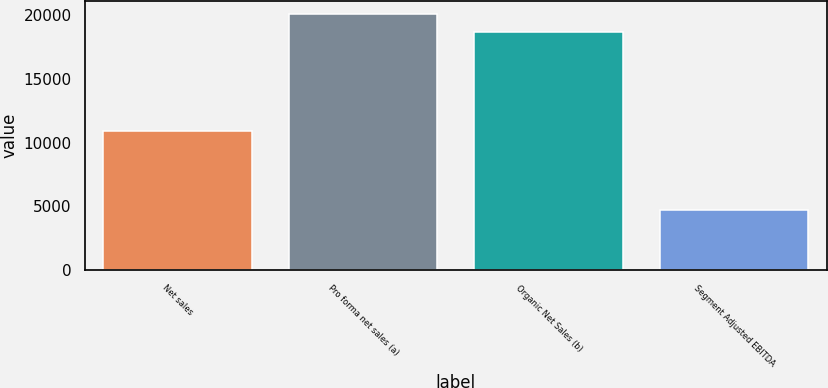Convert chart. <chart><loc_0><loc_0><loc_500><loc_500><bar_chart><fcel>Net sales<fcel>Pro forma net sales (a)<fcel>Organic Net Sales (b)<fcel>Segment Adjusted EBITDA<nl><fcel>10943<fcel>20123.2<fcel>18699<fcel>4690<nl></chart> 